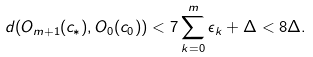Convert formula to latex. <formula><loc_0><loc_0><loc_500><loc_500>d ( O _ { m + 1 } ( c _ { * } ) , O _ { 0 } ( c _ { 0 } ) ) < 7 \sum _ { k = 0 } ^ { m } \epsilon _ { k } + \Delta < 8 \Delta .</formula> 